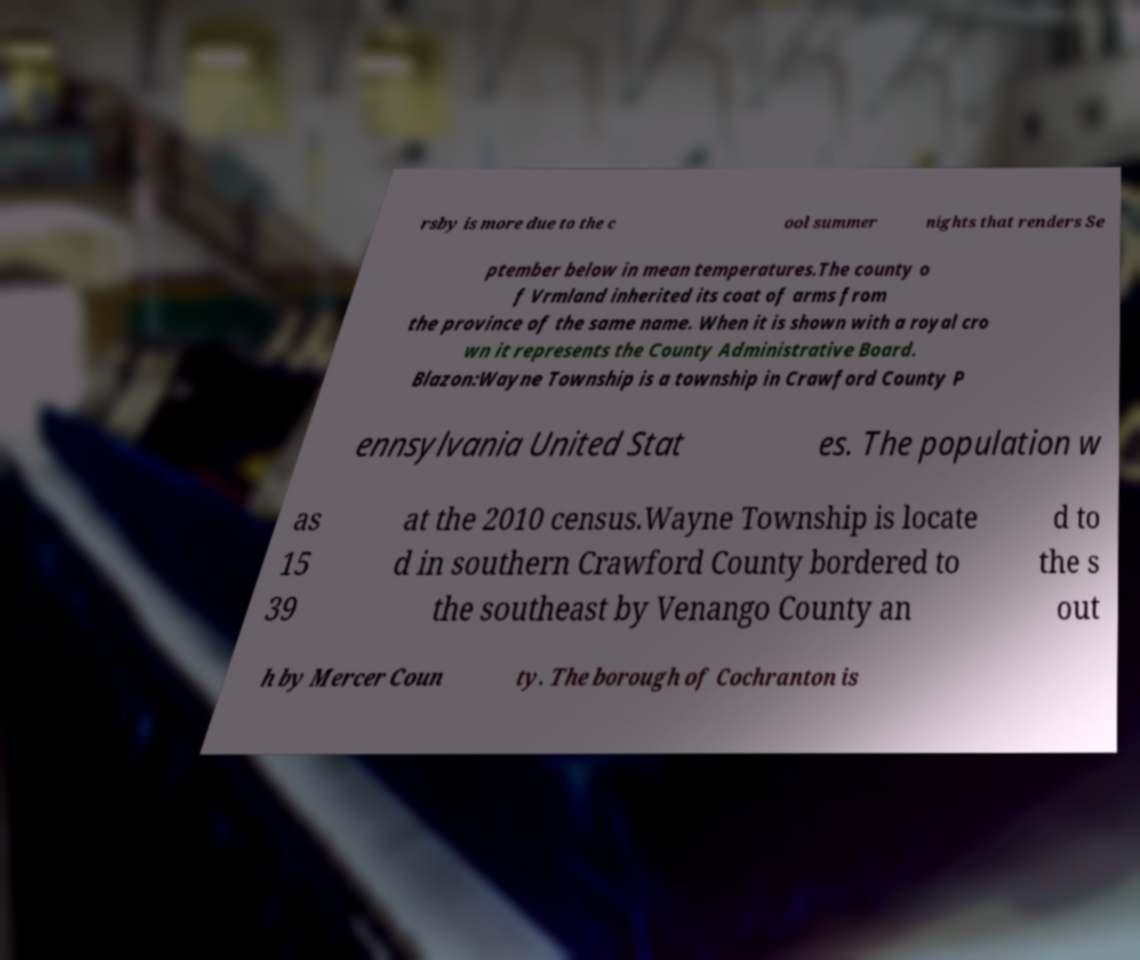Can you read and provide the text displayed in the image?This photo seems to have some interesting text. Can you extract and type it out for me? rsby is more due to the c ool summer nights that renders Se ptember below in mean temperatures.The county o f Vrmland inherited its coat of arms from the province of the same name. When it is shown with a royal cro wn it represents the County Administrative Board. Blazon:Wayne Township is a township in Crawford County P ennsylvania United Stat es. The population w as 15 39 at the 2010 census.Wayne Township is locate d in southern Crawford County bordered to the southeast by Venango County an d to the s out h by Mercer Coun ty. The borough of Cochranton is 